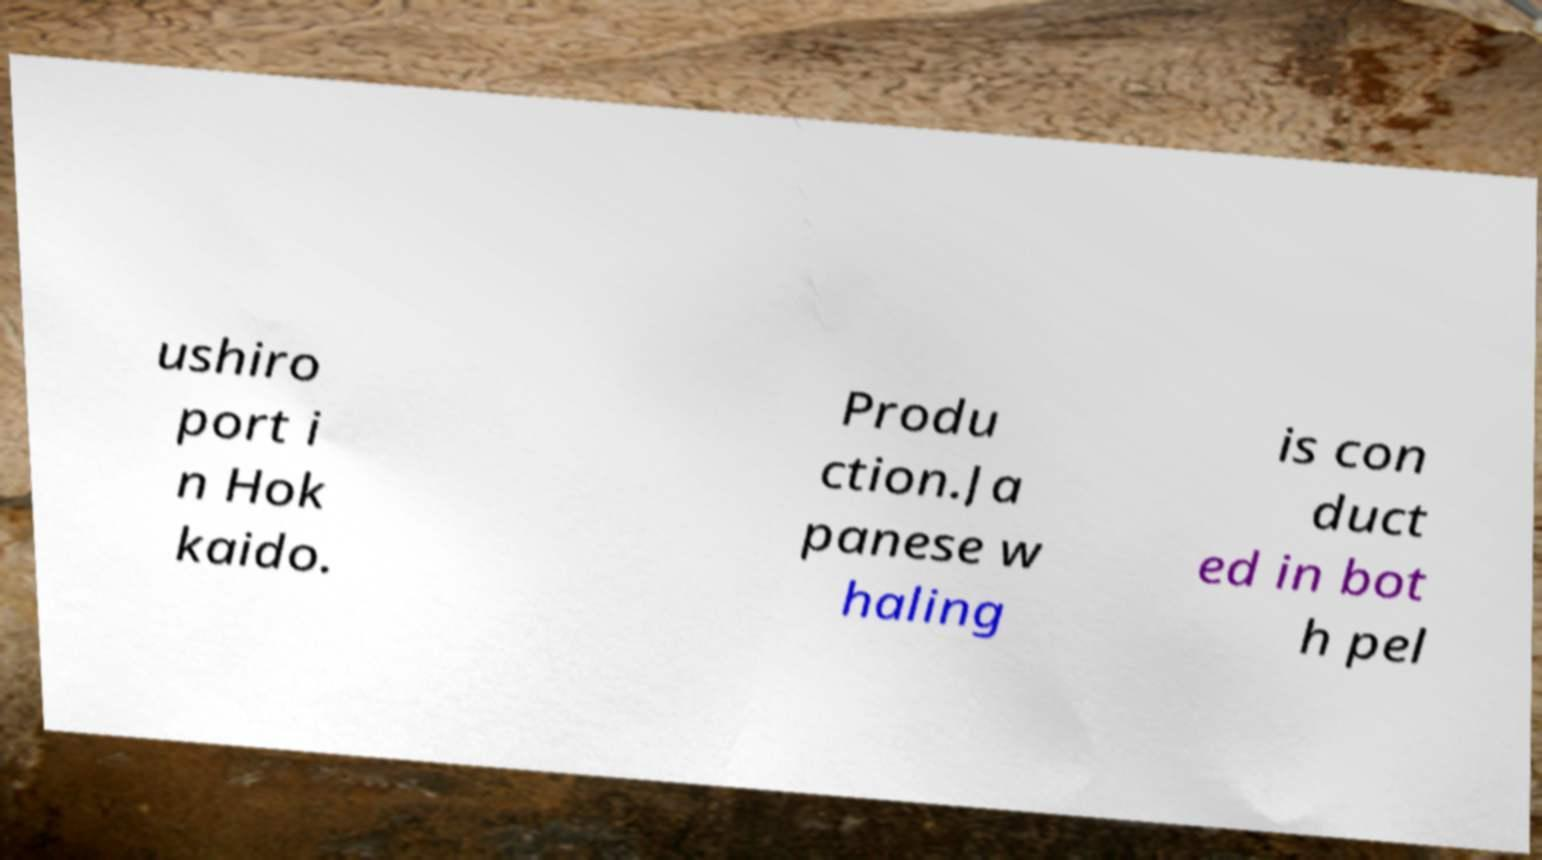Can you accurately transcribe the text from the provided image for me? ushiro port i n Hok kaido. Produ ction.Ja panese w haling is con duct ed in bot h pel 